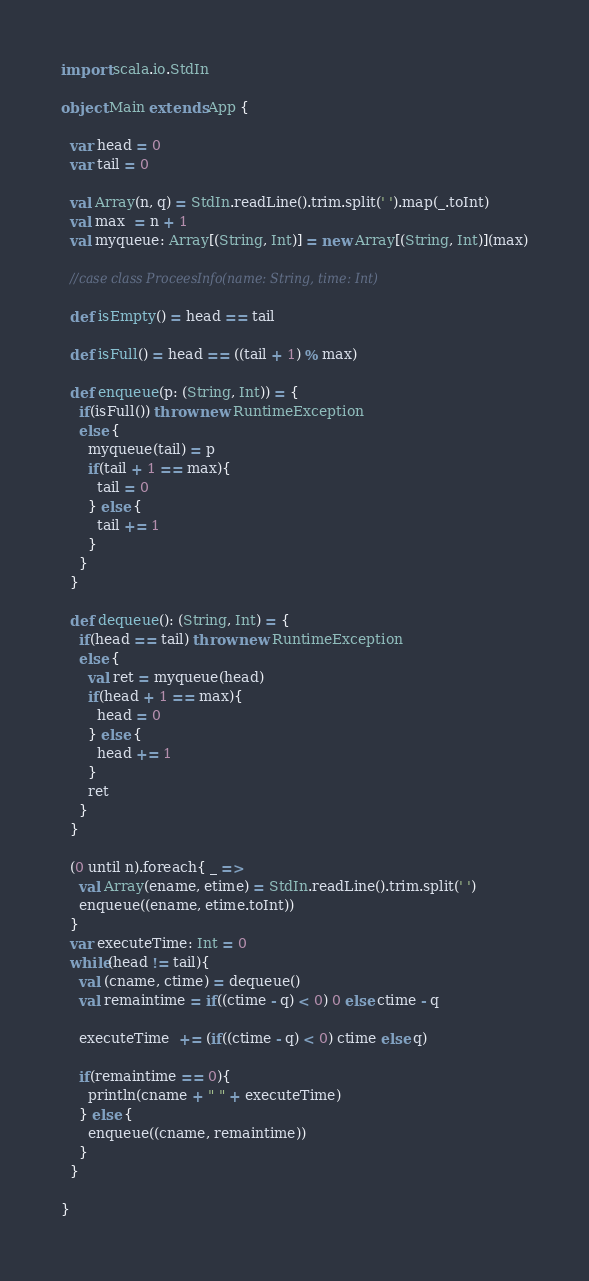Convert code to text. <code><loc_0><loc_0><loc_500><loc_500><_Scala_>import scala.io.StdIn

object Main extends App {

  var head = 0
  var tail = 0
  
  val Array(n, q) = StdIn.readLine().trim.split(' ').map(_.toInt)
  val max  = n + 1 
  val myqueue: Array[(String, Int)] = new Array[(String, Int)](max)

  //case class ProceesInfo(name: String, time: Int) 
  
  def isEmpty() = head == tail
  
  def isFull() = head == ((tail + 1) % max)
  
  def enqueue(p: (String, Int)) = {
    if(isFull()) throw new RuntimeException
    else {
      myqueue(tail) = p
      if(tail + 1 == max){
        tail = 0
      } else {
        tail += 1
      }
    }
  }
  
  def dequeue(): (String, Int) = {
    if(head == tail) throw new RuntimeException
    else {
      val ret = myqueue(head)
      if(head + 1 == max){
        head = 0
      } else {
        head += 1
      }
      ret
    }
  }
  
  (0 until n).foreach{ _ =>
    val Array(ename, etime) = StdIn.readLine().trim.split(' ')
    enqueue((ename, etime.toInt))
  }
  var executeTime: Int = 0
  while(head != tail){
    val (cname, ctime) = dequeue()
    val remaintime = if((ctime - q) < 0) 0 else ctime - q
    
    executeTime  += (if((ctime - q) < 0) ctime else q)
    
    if(remaintime == 0){
      println(cname + " " + executeTime)
    } else {
      enqueue((cname, remaintime))
    }
  }
  
}

</code> 